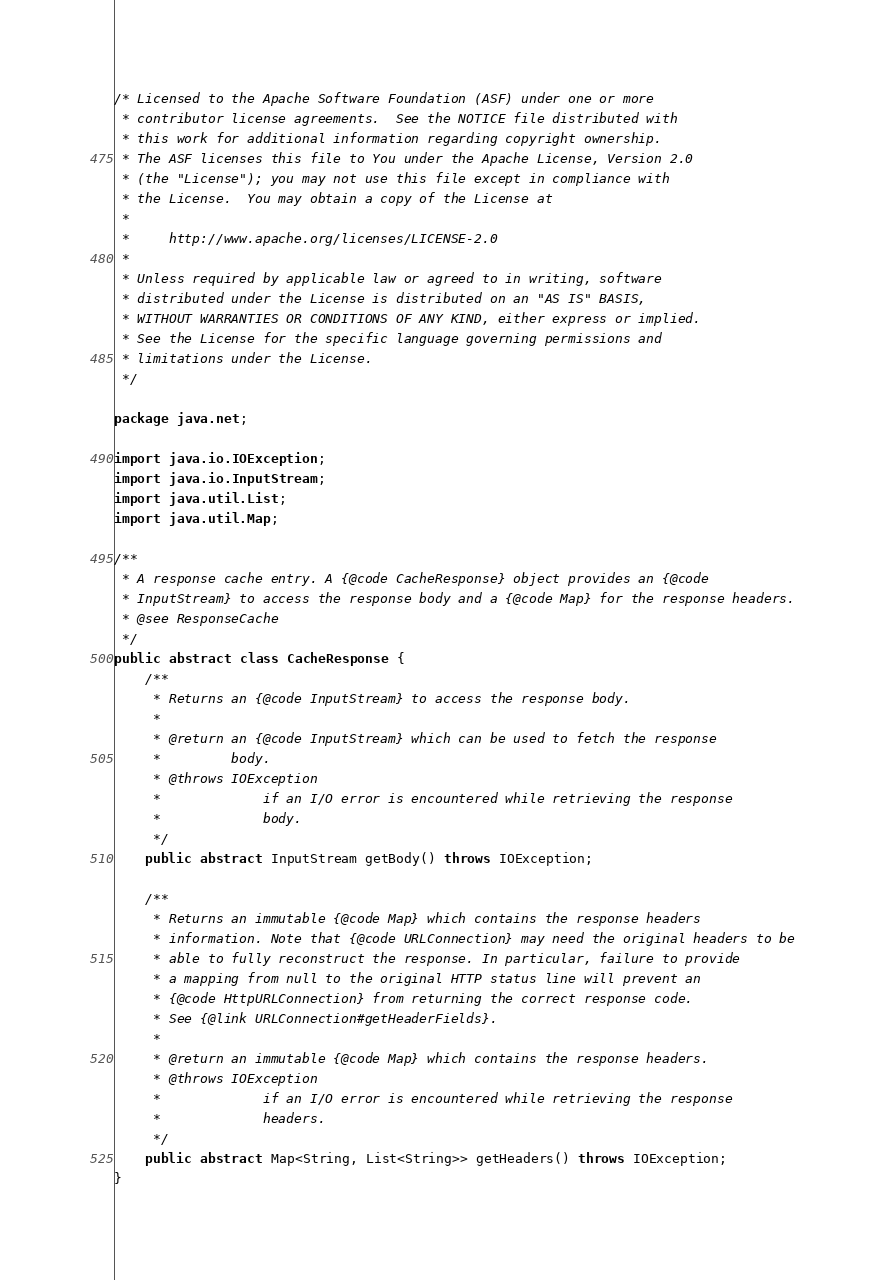<code> <loc_0><loc_0><loc_500><loc_500><_Java_>/* Licensed to the Apache Software Foundation (ASF) under one or more
 * contributor license agreements.  See the NOTICE file distributed with
 * this work for additional information regarding copyright ownership.
 * The ASF licenses this file to You under the Apache License, Version 2.0
 * (the "License"); you may not use this file except in compliance with
 * the License.  You may obtain a copy of the License at
 *
 *     http://www.apache.org/licenses/LICENSE-2.0
 *
 * Unless required by applicable law or agreed to in writing, software
 * distributed under the License is distributed on an "AS IS" BASIS,
 * WITHOUT WARRANTIES OR CONDITIONS OF ANY KIND, either express or implied.
 * See the License for the specific language governing permissions and
 * limitations under the License.
 */

package java.net;

import java.io.IOException;
import java.io.InputStream;
import java.util.List;
import java.util.Map;

/**
 * A response cache entry. A {@code CacheResponse} object provides an {@code
 * InputStream} to access the response body and a {@code Map} for the response headers.
 * @see ResponseCache
 */
public abstract class CacheResponse {
    /**
     * Returns an {@code InputStream} to access the response body.
     *
     * @return an {@code InputStream} which can be used to fetch the response
     *         body.
     * @throws IOException
     *             if an I/O error is encountered while retrieving the response
     *             body.
     */
    public abstract InputStream getBody() throws IOException;

    /**
     * Returns an immutable {@code Map} which contains the response headers
     * information. Note that {@code URLConnection} may need the original headers to be
     * able to fully reconstruct the response. In particular, failure to provide
     * a mapping from null to the original HTTP status line will prevent an
     * {@code HttpURLConnection} from returning the correct response code.
     * See {@link URLConnection#getHeaderFields}.
     *
     * @return an immutable {@code Map} which contains the response headers.
     * @throws IOException
     *             if an I/O error is encountered while retrieving the response
     *             headers.
     */
    public abstract Map<String, List<String>> getHeaders() throws IOException;
}
</code> 